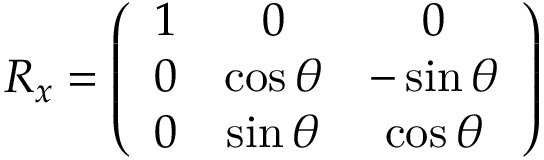<formula> <loc_0><loc_0><loc_500><loc_500>\begin{array} { r } { R _ { x } = \left ( \begin{array} { c c c } { 1 } & { 0 } & { 0 } \\ { 0 } & { \cos \theta } & { - \sin \theta } \\ { 0 } & { \sin \theta } & { \cos \theta } \end{array} \right ) } \end{array}</formula> 